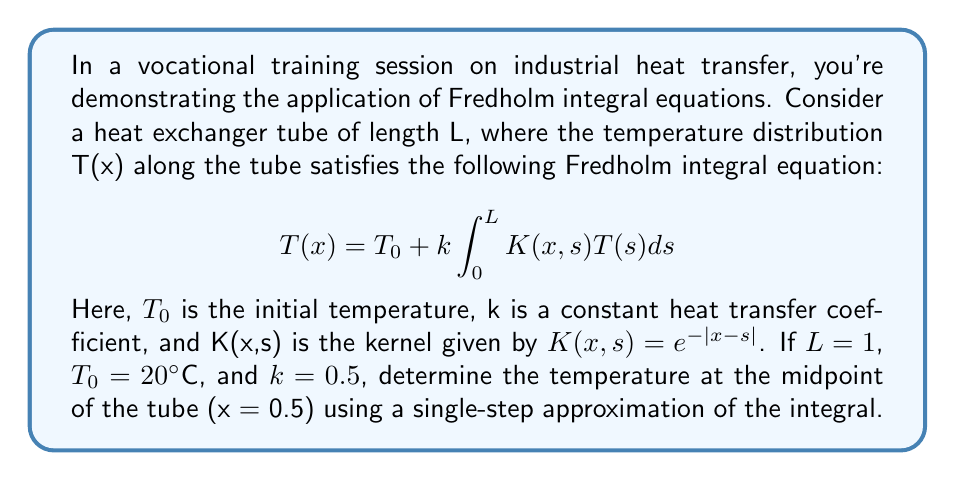Show me your answer to this math problem. Let's approach this step-by-step:

1) We're given the Fredholm integral equation:
   $$T(x) = T_0 + k \int_0^L K(x,s)T(s)ds$$

2) We need to find T(0.5), so we substitute x = 0.5:
   $$T(0.5) = T_0 + k \int_0^1 K(0.5,s)T(s)ds$$

3) We're told to use a single-step approximation. This means we'll approximate the integral using the midpoint rule with just one subinterval. The midpoint of [0,1] is 0.5, so:
   $$T(0.5) \approx T_0 + k \cdot 1 \cdot K(0.5,0.5)T(0.5)$$

4) Now, let's substitute the known values:
   $T_0 = 20$, $k = 0.5$, and $K(0.5,0.5) = e^{-|0.5-0.5|} = e^0 = 1$

5) Our equation becomes:
   $$T(0.5) \approx 20 + 0.5 \cdot 1 \cdot 1 \cdot T(0.5)$$

6) Simplify:
   $$T(0.5) \approx 20 + 0.5T(0.5)$$

7) Solve for T(0.5):
   $$0.5T(0.5) \approx 20$$
   $$T(0.5) \approx 40$$

Therefore, using this approximation, the temperature at the midpoint of the tube is approximately 40°C.
Answer: 40°C 